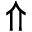<formula> <loc_0><loc_0><loc_500><loc_500>\Uparrow</formula> 